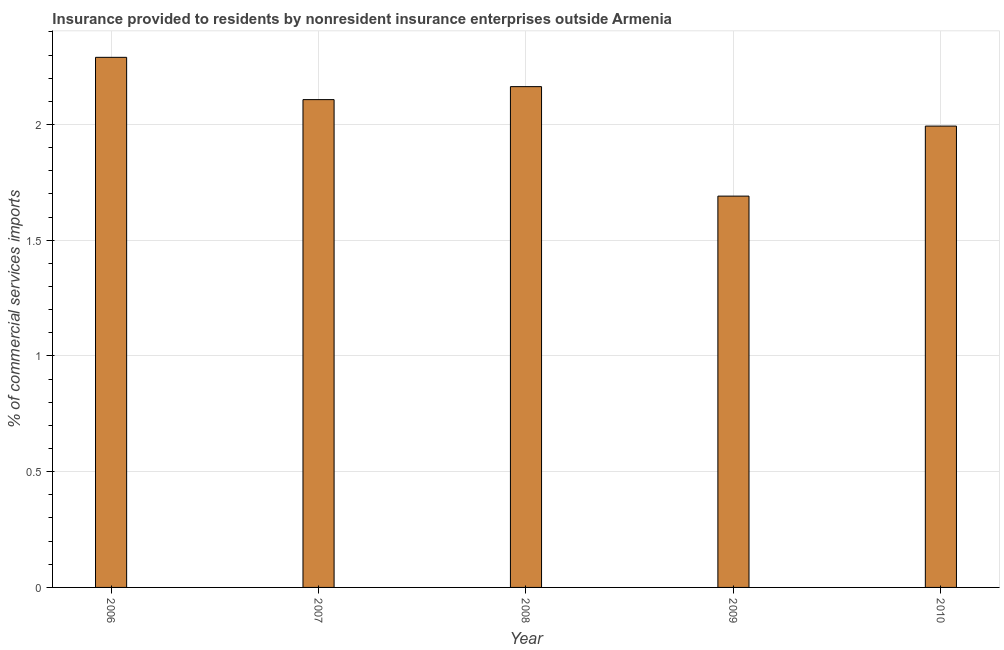What is the title of the graph?
Offer a very short reply. Insurance provided to residents by nonresident insurance enterprises outside Armenia. What is the label or title of the X-axis?
Ensure brevity in your answer.  Year. What is the label or title of the Y-axis?
Offer a terse response. % of commercial services imports. What is the insurance provided by non-residents in 2006?
Give a very brief answer. 2.29. Across all years, what is the maximum insurance provided by non-residents?
Give a very brief answer. 2.29. Across all years, what is the minimum insurance provided by non-residents?
Give a very brief answer. 1.69. What is the sum of the insurance provided by non-residents?
Your answer should be very brief. 10.25. What is the difference between the insurance provided by non-residents in 2008 and 2010?
Your answer should be very brief. 0.17. What is the average insurance provided by non-residents per year?
Make the answer very short. 2.05. What is the median insurance provided by non-residents?
Keep it short and to the point. 2.11. What is the ratio of the insurance provided by non-residents in 2008 to that in 2010?
Your answer should be compact. 1.08. Is the difference between the insurance provided by non-residents in 2006 and 2009 greater than the difference between any two years?
Make the answer very short. Yes. What is the difference between the highest and the second highest insurance provided by non-residents?
Your answer should be compact. 0.13. Is the sum of the insurance provided by non-residents in 2006 and 2008 greater than the maximum insurance provided by non-residents across all years?
Offer a terse response. Yes. How many years are there in the graph?
Your answer should be very brief. 5. What is the % of commercial services imports in 2006?
Offer a terse response. 2.29. What is the % of commercial services imports in 2007?
Provide a succinct answer. 2.11. What is the % of commercial services imports of 2008?
Your answer should be compact. 2.16. What is the % of commercial services imports in 2009?
Your response must be concise. 1.69. What is the % of commercial services imports of 2010?
Offer a very short reply. 1.99. What is the difference between the % of commercial services imports in 2006 and 2007?
Offer a terse response. 0.18. What is the difference between the % of commercial services imports in 2006 and 2008?
Your answer should be compact. 0.13. What is the difference between the % of commercial services imports in 2006 and 2009?
Your response must be concise. 0.6. What is the difference between the % of commercial services imports in 2006 and 2010?
Your response must be concise. 0.3. What is the difference between the % of commercial services imports in 2007 and 2008?
Provide a succinct answer. -0.06. What is the difference between the % of commercial services imports in 2007 and 2009?
Make the answer very short. 0.42. What is the difference between the % of commercial services imports in 2007 and 2010?
Ensure brevity in your answer.  0.11. What is the difference between the % of commercial services imports in 2008 and 2009?
Ensure brevity in your answer.  0.47. What is the difference between the % of commercial services imports in 2008 and 2010?
Keep it short and to the point. 0.17. What is the difference between the % of commercial services imports in 2009 and 2010?
Keep it short and to the point. -0.3. What is the ratio of the % of commercial services imports in 2006 to that in 2007?
Ensure brevity in your answer.  1.09. What is the ratio of the % of commercial services imports in 2006 to that in 2008?
Your answer should be very brief. 1.06. What is the ratio of the % of commercial services imports in 2006 to that in 2009?
Make the answer very short. 1.35. What is the ratio of the % of commercial services imports in 2006 to that in 2010?
Your response must be concise. 1.15. What is the ratio of the % of commercial services imports in 2007 to that in 2009?
Provide a short and direct response. 1.25. What is the ratio of the % of commercial services imports in 2007 to that in 2010?
Your answer should be very brief. 1.06. What is the ratio of the % of commercial services imports in 2008 to that in 2009?
Your response must be concise. 1.28. What is the ratio of the % of commercial services imports in 2008 to that in 2010?
Offer a very short reply. 1.08. What is the ratio of the % of commercial services imports in 2009 to that in 2010?
Make the answer very short. 0.85. 